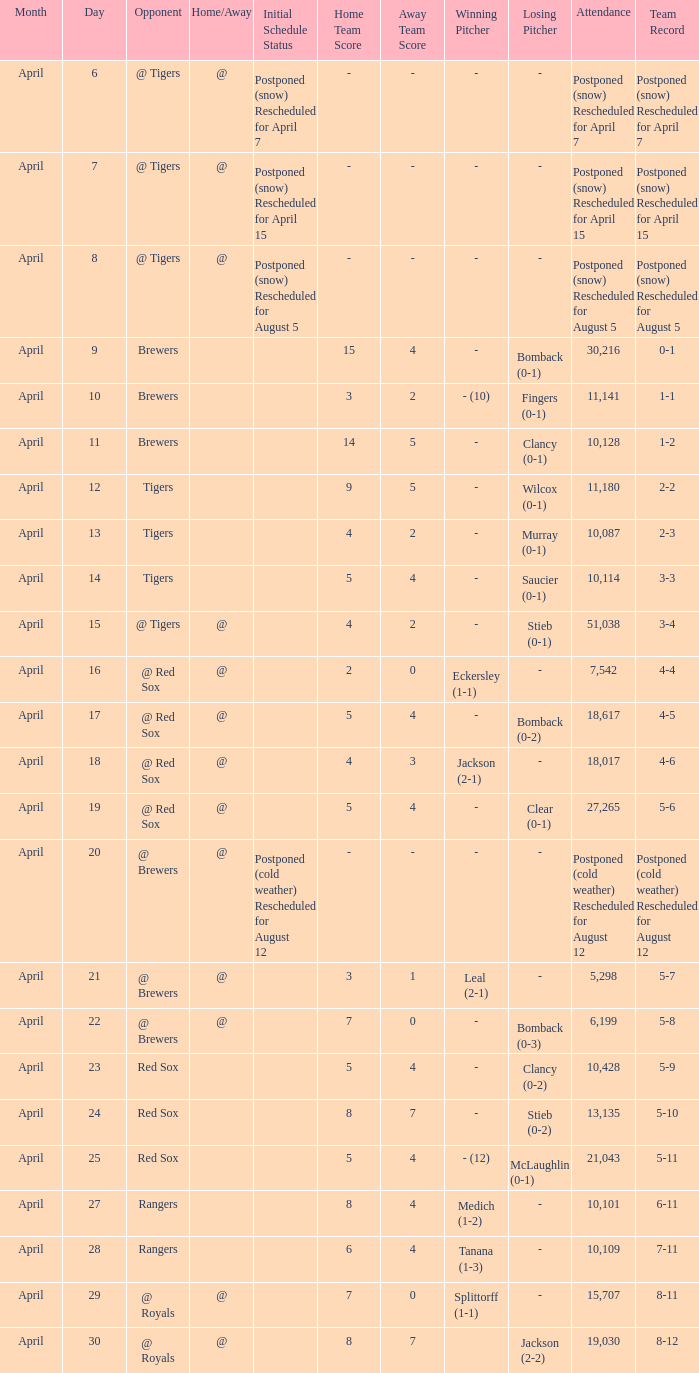What was the date for the game that had an attendance of 10,101? April 27. 